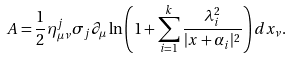Convert formula to latex. <formula><loc_0><loc_0><loc_500><loc_500>A = \frac { 1 } { 2 } { \eta } ^ { j } _ { \mu \nu } \sigma _ { j } \partial _ { \mu } \ln \left ( 1 + \sum ^ { k } _ { i = 1 } \frac { \lambda ^ { 2 } _ { i } } { | x + \alpha _ { i } | ^ { 2 } } \right ) d x _ { \nu } .</formula> 